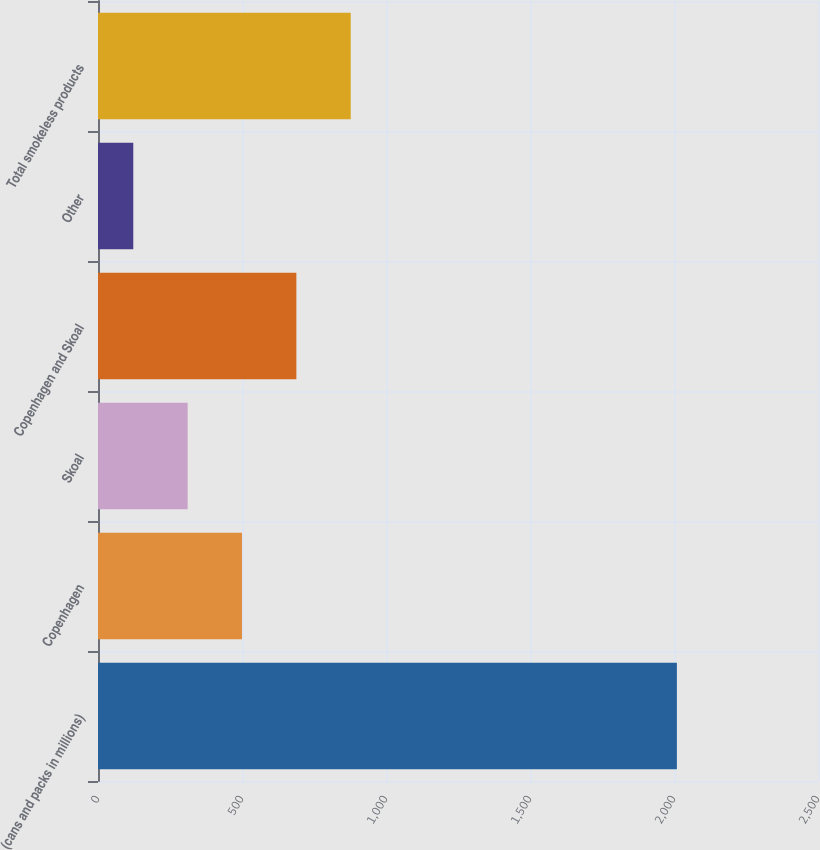Convert chart. <chart><loc_0><loc_0><loc_500><loc_500><bar_chart><fcel>(cans and packs in millions)<fcel>Copenhagen<fcel>Skoal<fcel>Copenhagen and Skoal<fcel>Other<fcel>Total smokeless products<nl><fcel>2010<fcel>500<fcel>311.25<fcel>688.75<fcel>122.5<fcel>877.5<nl></chart> 